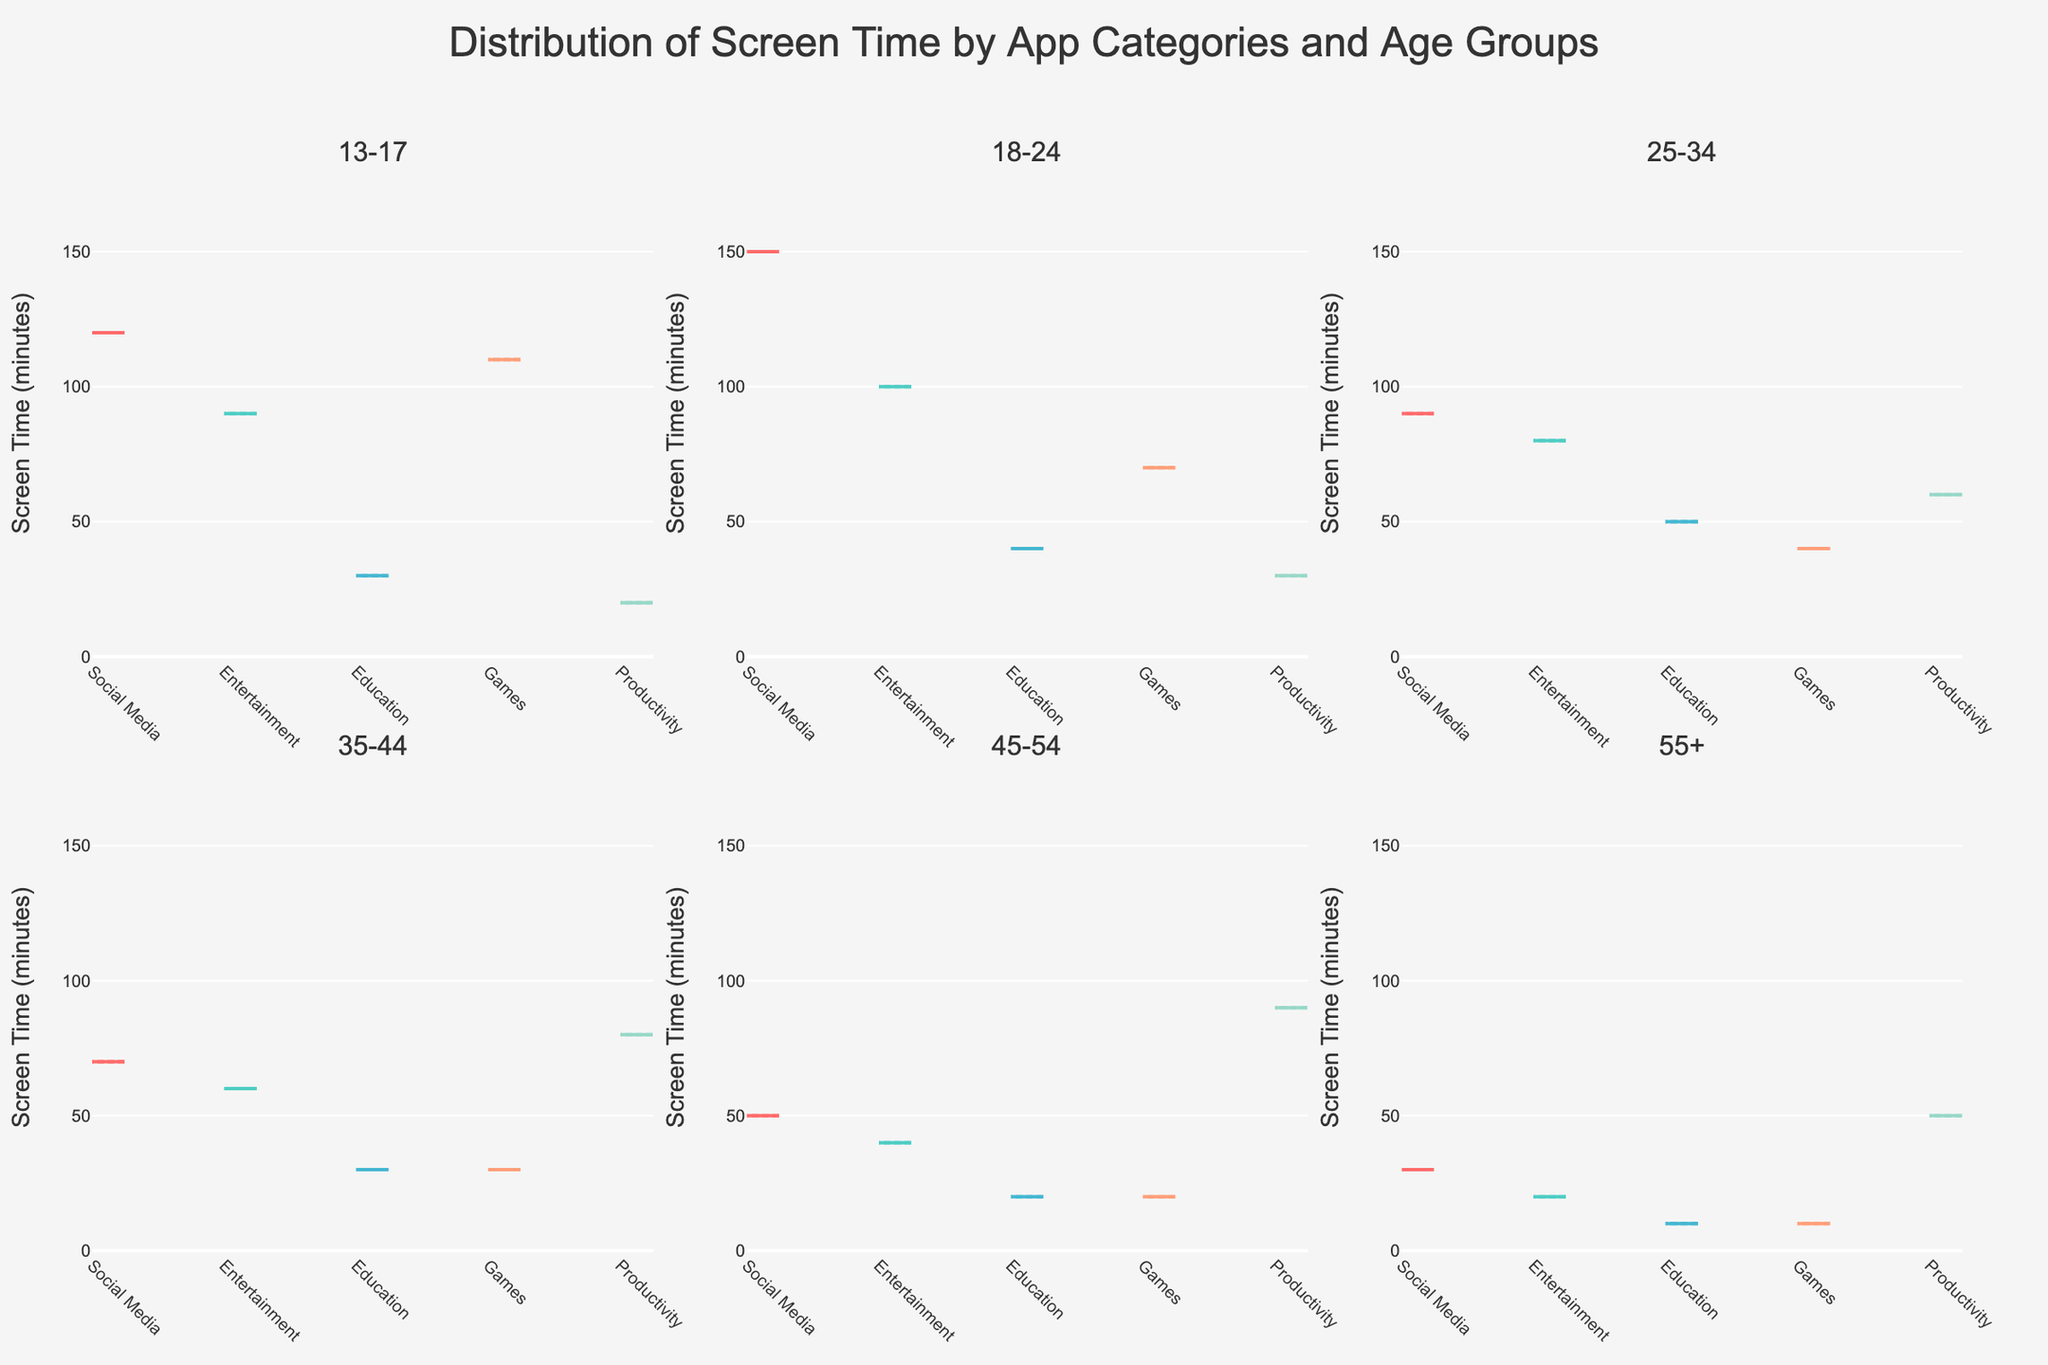What is the title of the figure? The title of the figure is typically displayed at the top center of the plot. Here, it reads "Distribution of Screen Time by App Categories and Age Groups".
Answer: Distribution of Screen Time by App Categories and Age Groups Which age group has the highest median screen time for social media? By observing each subplot and noting the position of the median line for social media (in red), you can see that the 18-24 age group has the highest median screen time for social media.
Answer: 18-24 Which category has the least variability in screen time for the 45-54 age group? For each category in the 45-54 age group subplot, we should compare the width of the violin plots. Productivity is the least variable as its width is the smallest.
Answer: Productivity Which age group shows the greatest range in screen time for games? By examining the games category (colored light blue) in each age group subplot, the 13-17 age group violin plot spreads the most vertically, indicating the greatest range.
Answer: 13-17 What is the overall trend in screen time for productivity applications as age increases? Looking at each age group's productivity category (colored teal), we can see that it generally increases as age increases, peaking in the 45-54 age group before decreasing for 55+.
Answer: Increases, then decreases How does screen time for entertainment differ between the 13-17 and 25-34 age groups? Compare the violin plots for entertainment in both 13-17 and 25-34 age groups. The 13-17 age group has a higher median and a wider range of screen time for entertainment than the 25-34 age group.
Answer: Higher and wider range in 13-17 Which age group uses the most screen time for educational purposes? The median line for each age group's education category (colored orange) indicates the central tendency. The 25-34 age group displays the highest median screen time for education.
Answer: 25-34 How does social media screen time trend from the youngest to the oldest group? Observe the medians in the social media category for all age groups from 13-17 to 55+. Screen time decreases consistently as age increases.
Answer: Decreases Between which two age groups is there the largest difference in median screen time for games? Compare the median lines for the games category across age groups. The biggest difference in median screen time for games appears between the 13-17 and 18-24 age groups.
Answer: 13-17 and 18-24 